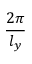Convert formula to latex. <formula><loc_0><loc_0><loc_500><loc_500>\frac { 2 \pi } { l _ { y } }</formula> 